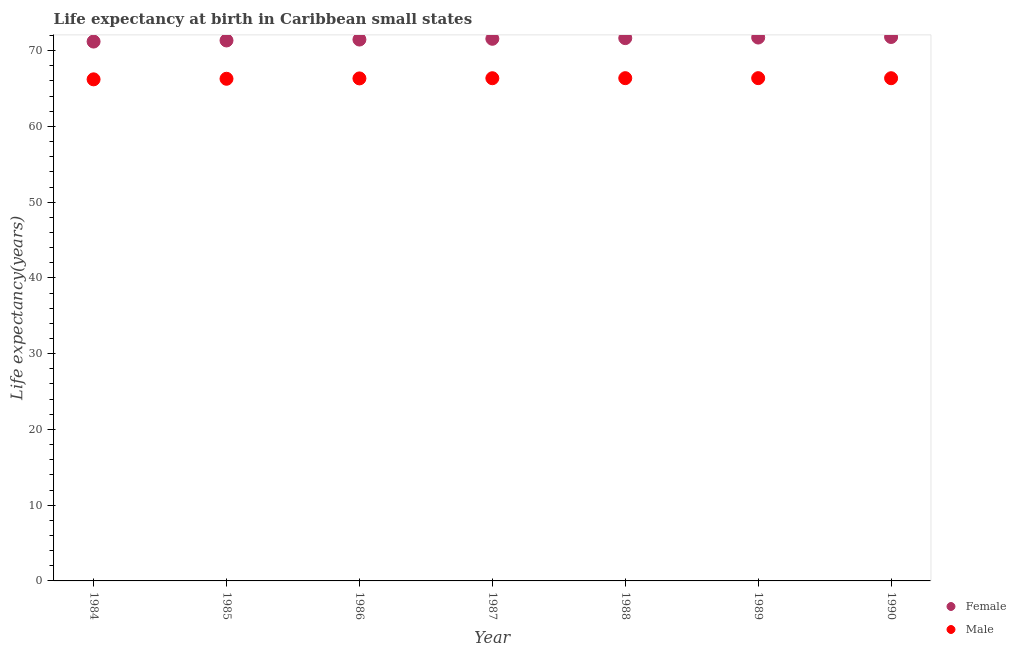What is the life expectancy(female) in 1989?
Your answer should be very brief. 71.73. Across all years, what is the maximum life expectancy(male)?
Give a very brief answer. 66.37. Across all years, what is the minimum life expectancy(male)?
Offer a terse response. 66.21. In which year was the life expectancy(male) maximum?
Provide a succinct answer. 1989. In which year was the life expectancy(female) minimum?
Provide a short and direct response. 1984. What is the total life expectancy(female) in the graph?
Ensure brevity in your answer.  500.76. What is the difference between the life expectancy(male) in 1984 and that in 1986?
Make the answer very short. -0.12. What is the difference between the life expectancy(female) in 1987 and the life expectancy(male) in 1984?
Make the answer very short. 5.35. What is the average life expectancy(female) per year?
Give a very brief answer. 71.54. In the year 1988, what is the difference between the life expectancy(male) and life expectancy(female)?
Keep it short and to the point. -5.28. In how many years, is the life expectancy(male) greater than 52 years?
Provide a short and direct response. 7. What is the ratio of the life expectancy(male) in 1987 to that in 1989?
Provide a succinct answer. 1. Is the life expectancy(male) in 1985 less than that in 1989?
Ensure brevity in your answer.  Yes. Is the difference between the life expectancy(female) in 1985 and 1989 greater than the difference between the life expectancy(male) in 1985 and 1989?
Your answer should be compact. No. What is the difference between the highest and the second highest life expectancy(female)?
Offer a terse response. 0.07. What is the difference between the highest and the lowest life expectancy(female)?
Provide a succinct answer. 0.6. Does the life expectancy(male) monotonically increase over the years?
Offer a very short reply. No. What is the difference between two consecutive major ticks on the Y-axis?
Give a very brief answer. 10. How many legend labels are there?
Make the answer very short. 2. How are the legend labels stacked?
Give a very brief answer. Vertical. What is the title of the graph?
Provide a short and direct response. Life expectancy at birth in Caribbean small states. Does "Old" appear as one of the legend labels in the graph?
Keep it short and to the point. No. What is the label or title of the X-axis?
Ensure brevity in your answer.  Year. What is the label or title of the Y-axis?
Give a very brief answer. Life expectancy(years). What is the Life expectancy(years) in Female in 1984?
Provide a short and direct response. 71.2. What is the Life expectancy(years) in Male in 1984?
Your answer should be compact. 66.21. What is the Life expectancy(years) in Female in 1985?
Your answer should be compact. 71.34. What is the Life expectancy(years) of Male in 1985?
Give a very brief answer. 66.29. What is the Life expectancy(years) in Female in 1986?
Your answer should be very brief. 71.47. What is the Life expectancy(years) of Male in 1986?
Offer a very short reply. 66.34. What is the Life expectancy(years) in Female in 1987?
Keep it short and to the point. 71.57. What is the Life expectancy(years) of Male in 1987?
Provide a short and direct response. 66.36. What is the Life expectancy(years) in Female in 1988?
Give a very brief answer. 71.65. What is the Life expectancy(years) of Male in 1988?
Your response must be concise. 66.37. What is the Life expectancy(years) of Female in 1989?
Your answer should be very brief. 71.73. What is the Life expectancy(years) of Male in 1989?
Make the answer very short. 66.37. What is the Life expectancy(years) in Female in 1990?
Keep it short and to the point. 71.8. What is the Life expectancy(years) of Male in 1990?
Your answer should be very brief. 66.36. Across all years, what is the maximum Life expectancy(years) of Female?
Your answer should be very brief. 71.8. Across all years, what is the maximum Life expectancy(years) in Male?
Your response must be concise. 66.37. Across all years, what is the minimum Life expectancy(years) of Female?
Your answer should be compact. 71.2. Across all years, what is the minimum Life expectancy(years) of Male?
Make the answer very short. 66.21. What is the total Life expectancy(years) in Female in the graph?
Your answer should be compact. 500.76. What is the total Life expectancy(years) in Male in the graph?
Offer a terse response. 464.29. What is the difference between the Life expectancy(years) of Female in 1984 and that in 1985?
Provide a succinct answer. -0.15. What is the difference between the Life expectancy(years) in Male in 1984 and that in 1985?
Provide a succinct answer. -0.08. What is the difference between the Life expectancy(years) of Female in 1984 and that in 1986?
Your answer should be very brief. -0.27. What is the difference between the Life expectancy(years) of Male in 1984 and that in 1986?
Offer a terse response. -0.12. What is the difference between the Life expectancy(years) of Female in 1984 and that in 1987?
Your answer should be compact. -0.37. What is the difference between the Life expectancy(years) in Male in 1984 and that in 1987?
Provide a succinct answer. -0.15. What is the difference between the Life expectancy(years) of Female in 1984 and that in 1988?
Keep it short and to the point. -0.45. What is the difference between the Life expectancy(years) in Male in 1984 and that in 1988?
Offer a terse response. -0.15. What is the difference between the Life expectancy(years) in Female in 1984 and that in 1989?
Provide a succinct answer. -0.53. What is the difference between the Life expectancy(years) of Male in 1984 and that in 1989?
Offer a terse response. -0.16. What is the difference between the Life expectancy(years) in Female in 1984 and that in 1990?
Your response must be concise. -0.6. What is the difference between the Life expectancy(years) in Male in 1984 and that in 1990?
Offer a terse response. -0.15. What is the difference between the Life expectancy(years) in Female in 1985 and that in 1986?
Your answer should be very brief. -0.12. What is the difference between the Life expectancy(years) in Male in 1985 and that in 1986?
Provide a succinct answer. -0.05. What is the difference between the Life expectancy(years) in Female in 1985 and that in 1987?
Your response must be concise. -0.22. What is the difference between the Life expectancy(years) in Male in 1985 and that in 1987?
Offer a very short reply. -0.07. What is the difference between the Life expectancy(years) in Female in 1985 and that in 1988?
Offer a very short reply. -0.31. What is the difference between the Life expectancy(years) in Male in 1985 and that in 1988?
Provide a succinct answer. -0.08. What is the difference between the Life expectancy(years) of Female in 1985 and that in 1989?
Provide a succinct answer. -0.39. What is the difference between the Life expectancy(years) in Male in 1985 and that in 1989?
Make the answer very short. -0.08. What is the difference between the Life expectancy(years) of Female in 1985 and that in 1990?
Your answer should be very brief. -0.46. What is the difference between the Life expectancy(years) of Male in 1985 and that in 1990?
Give a very brief answer. -0.07. What is the difference between the Life expectancy(years) in Female in 1986 and that in 1987?
Provide a short and direct response. -0.1. What is the difference between the Life expectancy(years) in Male in 1986 and that in 1987?
Your answer should be compact. -0.02. What is the difference between the Life expectancy(years) in Female in 1986 and that in 1988?
Make the answer very short. -0.19. What is the difference between the Life expectancy(years) in Male in 1986 and that in 1988?
Ensure brevity in your answer.  -0.03. What is the difference between the Life expectancy(years) of Female in 1986 and that in 1989?
Keep it short and to the point. -0.27. What is the difference between the Life expectancy(years) of Male in 1986 and that in 1989?
Keep it short and to the point. -0.03. What is the difference between the Life expectancy(years) in Female in 1986 and that in 1990?
Give a very brief answer. -0.34. What is the difference between the Life expectancy(years) in Male in 1986 and that in 1990?
Provide a succinct answer. -0.03. What is the difference between the Life expectancy(years) of Female in 1987 and that in 1988?
Give a very brief answer. -0.09. What is the difference between the Life expectancy(years) in Male in 1987 and that in 1988?
Offer a terse response. -0.01. What is the difference between the Life expectancy(years) of Female in 1987 and that in 1989?
Provide a succinct answer. -0.17. What is the difference between the Life expectancy(years) in Male in 1987 and that in 1989?
Provide a succinct answer. -0.01. What is the difference between the Life expectancy(years) of Female in 1987 and that in 1990?
Keep it short and to the point. -0.24. What is the difference between the Life expectancy(years) in Male in 1987 and that in 1990?
Ensure brevity in your answer.  -0. What is the difference between the Life expectancy(years) of Female in 1988 and that in 1989?
Provide a succinct answer. -0.08. What is the difference between the Life expectancy(years) of Male in 1988 and that in 1989?
Ensure brevity in your answer.  -0. What is the difference between the Life expectancy(years) of Female in 1988 and that in 1990?
Offer a very short reply. -0.15. What is the difference between the Life expectancy(years) of Male in 1988 and that in 1990?
Provide a short and direct response. 0.01. What is the difference between the Life expectancy(years) of Female in 1989 and that in 1990?
Offer a very short reply. -0.07. What is the difference between the Life expectancy(years) of Male in 1989 and that in 1990?
Your answer should be very brief. 0.01. What is the difference between the Life expectancy(years) in Female in 1984 and the Life expectancy(years) in Male in 1985?
Offer a terse response. 4.91. What is the difference between the Life expectancy(years) in Female in 1984 and the Life expectancy(years) in Male in 1986?
Ensure brevity in your answer.  4.86. What is the difference between the Life expectancy(years) in Female in 1984 and the Life expectancy(years) in Male in 1987?
Offer a very short reply. 4.84. What is the difference between the Life expectancy(years) of Female in 1984 and the Life expectancy(years) of Male in 1988?
Provide a short and direct response. 4.83. What is the difference between the Life expectancy(years) in Female in 1984 and the Life expectancy(years) in Male in 1989?
Offer a very short reply. 4.83. What is the difference between the Life expectancy(years) of Female in 1984 and the Life expectancy(years) of Male in 1990?
Your answer should be compact. 4.84. What is the difference between the Life expectancy(years) of Female in 1985 and the Life expectancy(years) of Male in 1986?
Provide a succinct answer. 5.01. What is the difference between the Life expectancy(years) in Female in 1985 and the Life expectancy(years) in Male in 1987?
Ensure brevity in your answer.  4.98. What is the difference between the Life expectancy(years) in Female in 1985 and the Life expectancy(years) in Male in 1988?
Keep it short and to the point. 4.98. What is the difference between the Life expectancy(years) in Female in 1985 and the Life expectancy(years) in Male in 1989?
Your answer should be compact. 4.98. What is the difference between the Life expectancy(years) of Female in 1985 and the Life expectancy(years) of Male in 1990?
Offer a terse response. 4.98. What is the difference between the Life expectancy(years) of Female in 1986 and the Life expectancy(years) of Male in 1987?
Your answer should be compact. 5.11. What is the difference between the Life expectancy(years) of Female in 1986 and the Life expectancy(years) of Male in 1988?
Give a very brief answer. 5.1. What is the difference between the Life expectancy(years) of Female in 1986 and the Life expectancy(years) of Male in 1989?
Keep it short and to the point. 5.1. What is the difference between the Life expectancy(years) of Female in 1986 and the Life expectancy(years) of Male in 1990?
Your response must be concise. 5.1. What is the difference between the Life expectancy(years) of Female in 1987 and the Life expectancy(years) of Male in 1988?
Give a very brief answer. 5.2. What is the difference between the Life expectancy(years) in Female in 1987 and the Life expectancy(years) in Male in 1989?
Offer a terse response. 5.2. What is the difference between the Life expectancy(years) of Female in 1987 and the Life expectancy(years) of Male in 1990?
Give a very brief answer. 5.21. What is the difference between the Life expectancy(years) in Female in 1988 and the Life expectancy(years) in Male in 1989?
Your answer should be very brief. 5.28. What is the difference between the Life expectancy(years) of Female in 1988 and the Life expectancy(years) of Male in 1990?
Your answer should be very brief. 5.29. What is the difference between the Life expectancy(years) of Female in 1989 and the Life expectancy(years) of Male in 1990?
Your response must be concise. 5.37. What is the average Life expectancy(years) of Female per year?
Ensure brevity in your answer.  71.54. What is the average Life expectancy(years) of Male per year?
Keep it short and to the point. 66.33. In the year 1984, what is the difference between the Life expectancy(years) of Female and Life expectancy(years) of Male?
Provide a succinct answer. 4.99. In the year 1985, what is the difference between the Life expectancy(years) in Female and Life expectancy(years) in Male?
Offer a very short reply. 5.06. In the year 1986, what is the difference between the Life expectancy(years) in Female and Life expectancy(years) in Male?
Your answer should be compact. 5.13. In the year 1987, what is the difference between the Life expectancy(years) in Female and Life expectancy(years) in Male?
Make the answer very short. 5.21. In the year 1988, what is the difference between the Life expectancy(years) in Female and Life expectancy(years) in Male?
Make the answer very short. 5.28. In the year 1989, what is the difference between the Life expectancy(years) of Female and Life expectancy(years) of Male?
Make the answer very short. 5.36. In the year 1990, what is the difference between the Life expectancy(years) of Female and Life expectancy(years) of Male?
Your answer should be compact. 5.44. What is the ratio of the Life expectancy(years) in Female in 1984 to that in 1985?
Offer a very short reply. 1. What is the ratio of the Life expectancy(years) of Male in 1984 to that in 1985?
Provide a short and direct response. 1. What is the ratio of the Life expectancy(years) in Female in 1984 to that in 1986?
Make the answer very short. 1. What is the ratio of the Life expectancy(years) in Male in 1984 to that in 1986?
Make the answer very short. 1. What is the ratio of the Life expectancy(years) of Male in 1984 to that in 1988?
Keep it short and to the point. 1. What is the ratio of the Life expectancy(years) of Male in 1984 to that in 1989?
Your answer should be compact. 1. What is the ratio of the Life expectancy(years) of Female in 1984 to that in 1990?
Give a very brief answer. 0.99. What is the ratio of the Life expectancy(years) in Male in 1985 to that in 1986?
Offer a very short reply. 1. What is the ratio of the Life expectancy(years) of Male in 1985 to that in 1988?
Give a very brief answer. 1. What is the ratio of the Life expectancy(years) of Male in 1985 to that in 1990?
Your response must be concise. 1. What is the ratio of the Life expectancy(years) of Female in 1986 to that in 1988?
Your answer should be compact. 1. What is the ratio of the Life expectancy(years) in Female in 1986 to that in 1989?
Make the answer very short. 1. What is the ratio of the Life expectancy(years) in Male in 1986 to that in 1989?
Offer a terse response. 1. What is the ratio of the Life expectancy(years) of Female in 1986 to that in 1990?
Give a very brief answer. 1. What is the ratio of the Life expectancy(years) in Female in 1987 to that in 1988?
Provide a short and direct response. 1. What is the ratio of the Life expectancy(years) in Male in 1987 to that in 1988?
Provide a succinct answer. 1. What is the ratio of the Life expectancy(years) in Female in 1987 to that in 1989?
Your answer should be very brief. 1. What is the ratio of the Life expectancy(years) in Female in 1987 to that in 1990?
Your answer should be compact. 1. What is the ratio of the Life expectancy(years) of Male in 1987 to that in 1990?
Ensure brevity in your answer.  1. What is the ratio of the Life expectancy(years) of Male in 1988 to that in 1989?
Offer a very short reply. 1. What is the ratio of the Life expectancy(years) in Female in 1988 to that in 1990?
Offer a terse response. 1. What is the ratio of the Life expectancy(years) in Female in 1989 to that in 1990?
Keep it short and to the point. 1. What is the ratio of the Life expectancy(years) in Male in 1989 to that in 1990?
Ensure brevity in your answer.  1. What is the difference between the highest and the second highest Life expectancy(years) in Female?
Provide a short and direct response. 0.07. What is the difference between the highest and the second highest Life expectancy(years) in Male?
Make the answer very short. 0. What is the difference between the highest and the lowest Life expectancy(years) in Female?
Offer a terse response. 0.6. What is the difference between the highest and the lowest Life expectancy(years) in Male?
Your answer should be very brief. 0.16. 